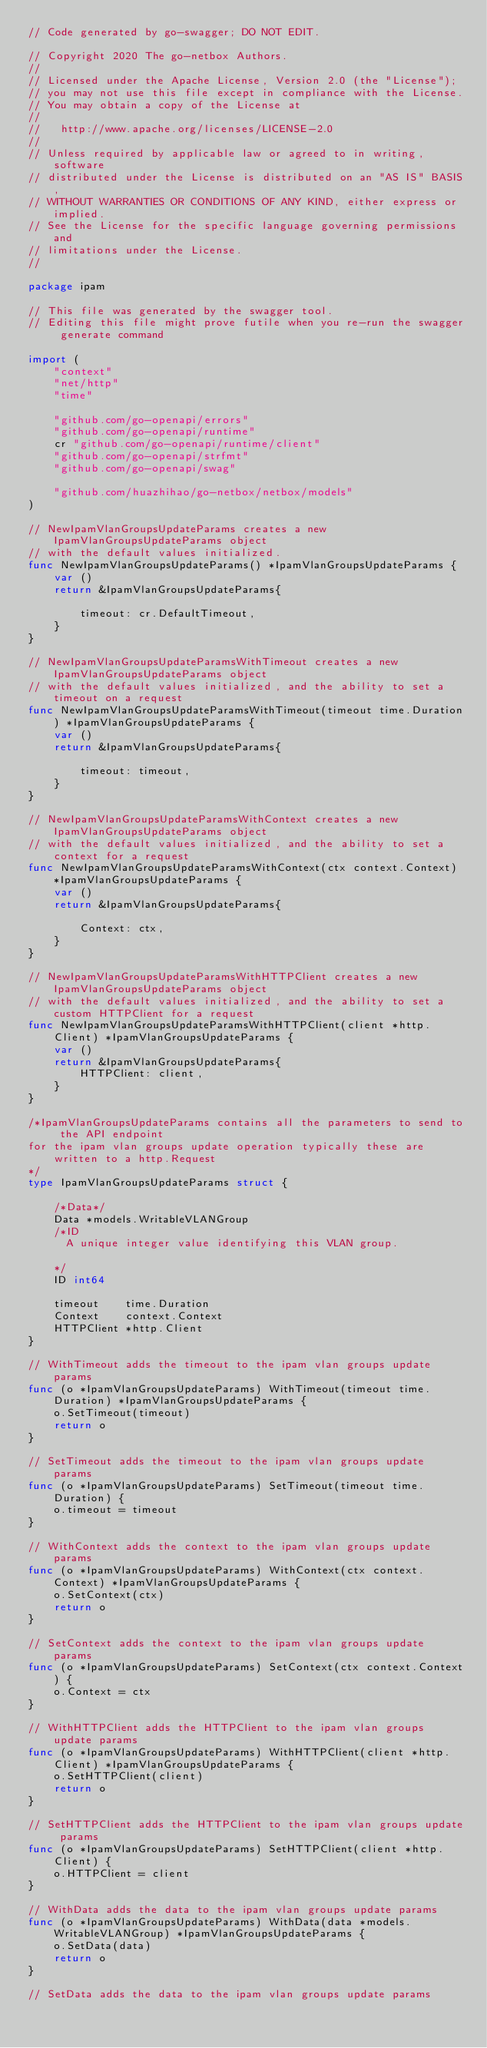Convert code to text. <code><loc_0><loc_0><loc_500><loc_500><_Go_>// Code generated by go-swagger; DO NOT EDIT.

// Copyright 2020 The go-netbox Authors.
//
// Licensed under the Apache License, Version 2.0 (the "License");
// you may not use this file except in compliance with the License.
// You may obtain a copy of the License at
//
//   http://www.apache.org/licenses/LICENSE-2.0
//
// Unless required by applicable law or agreed to in writing, software
// distributed under the License is distributed on an "AS IS" BASIS,
// WITHOUT WARRANTIES OR CONDITIONS OF ANY KIND, either express or implied.
// See the License for the specific language governing permissions and
// limitations under the License.
//

package ipam

// This file was generated by the swagger tool.
// Editing this file might prove futile when you re-run the swagger generate command

import (
	"context"
	"net/http"
	"time"

	"github.com/go-openapi/errors"
	"github.com/go-openapi/runtime"
	cr "github.com/go-openapi/runtime/client"
	"github.com/go-openapi/strfmt"
	"github.com/go-openapi/swag"

	"github.com/huazhihao/go-netbox/netbox/models"
)

// NewIpamVlanGroupsUpdateParams creates a new IpamVlanGroupsUpdateParams object
// with the default values initialized.
func NewIpamVlanGroupsUpdateParams() *IpamVlanGroupsUpdateParams {
	var ()
	return &IpamVlanGroupsUpdateParams{

		timeout: cr.DefaultTimeout,
	}
}

// NewIpamVlanGroupsUpdateParamsWithTimeout creates a new IpamVlanGroupsUpdateParams object
// with the default values initialized, and the ability to set a timeout on a request
func NewIpamVlanGroupsUpdateParamsWithTimeout(timeout time.Duration) *IpamVlanGroupsUpdateParams {
	var ()
	return &IpamVlanGroupsUpdateParams{

		timeout: timeout,
	}
}

// NewIpamVlanGroupsUpdateParamsWithContext creates a new IpamVlanGroupsUpdateParams object
// with the default values initialized, and the ability to set a context for a request
func NewIpamVlanGroupsUpdateParamsWithContext(ctx context.Context) *IpamVlanGroupsUpdateParams {
	var ()
	return &IpamVlanGroupsUpdateParams{

		Context: ctx,
	}
}

// NewIpamVlanGroupsUpdateParamsWithHTTPClient creates a new IpamVlanGroupsUpdateParams object
// with the default values initialized, and the ability to set a custom HTTPClient for a request
func NewIpamVlanGroupsUpdateParamsWithHTTPClient(client *http.Client) *IpamVlanGroupsUpdateParams {
	var ()
	return &IpamVlanGroupsUpdateParams{
		HTTPClient: client,
	}
}

/*IpamVlanGroupsUpdateParams contains all the parameters to send to the API endpoint
for the ipam vlan groups update operation typically these are written to a http.Request
*/
type IpamVlanGroupsUpdateParams struct {

	/*Data*/
	Data *models.WritableVLANGroup
	/*ID
	  A unique integer value identifying this VLAN group.

	*/
	ID int64

	timeout    time.Duration
	Context    context.Context
	HTTPClient *http.Client
}

// WithTimeout adds the timeout to the ipam vlan groups update params
func (o *IpamVlanGroupsUpdateParams) WithTimeout(timeout time.Duration) *IpamVlanGroupsUpdateParams {
	o.SetTimeout(timeout)
	return o
}

// SetTimeout adds the timeout to the ipam vlan groups update params
func (o *IpamVlanGroupsUpdateParams) SetTimeout(timeout time.Duration) {
	o.timeout = timeout
}

// WithContext adds the context to the ipam vlan groups update params
func (o *IpamVlanGroupsUpdateParams) WithContext(ctx context.Context) *IpamVlanGroupsUpdateParams {
	o.SetContext(ctx)
	return o
}

// SetContext adds the context to the ipam vlan groups update params
func (o *IpamVlanGroupsUpdateParams) SetContext(ctx context.Context) {
	o.Context = ctx
}

// WithHTTPClient adds the HTTPClient to the ipam vlan groups update params
func (o *IpamVlanGroupsUpdateParams) WithHTTPClient(client *http.Client) *IpamVlanGroupsUpdateParams {
	o.SetHTTPClient(client)
	return o
}

// SetHTTPClient adds the HTTPClient to the ipam vlan groups update params
func (o *IpamVlanGroupsUpdateParams) SetHTTPClient(client *http.Client) {
	o.HTTPClient = client
}

// WithData adds the data to the ipam vlan groups update params
func (o *IpamVlanGroupsUpdateParams) WithData(data *models.WritableVLANGroup) *IpamVlanGroupsUpdateParams {
	o.SetData(data)
	return o
}

// SetData adds the data to the ipam vlan groups update params</code> 